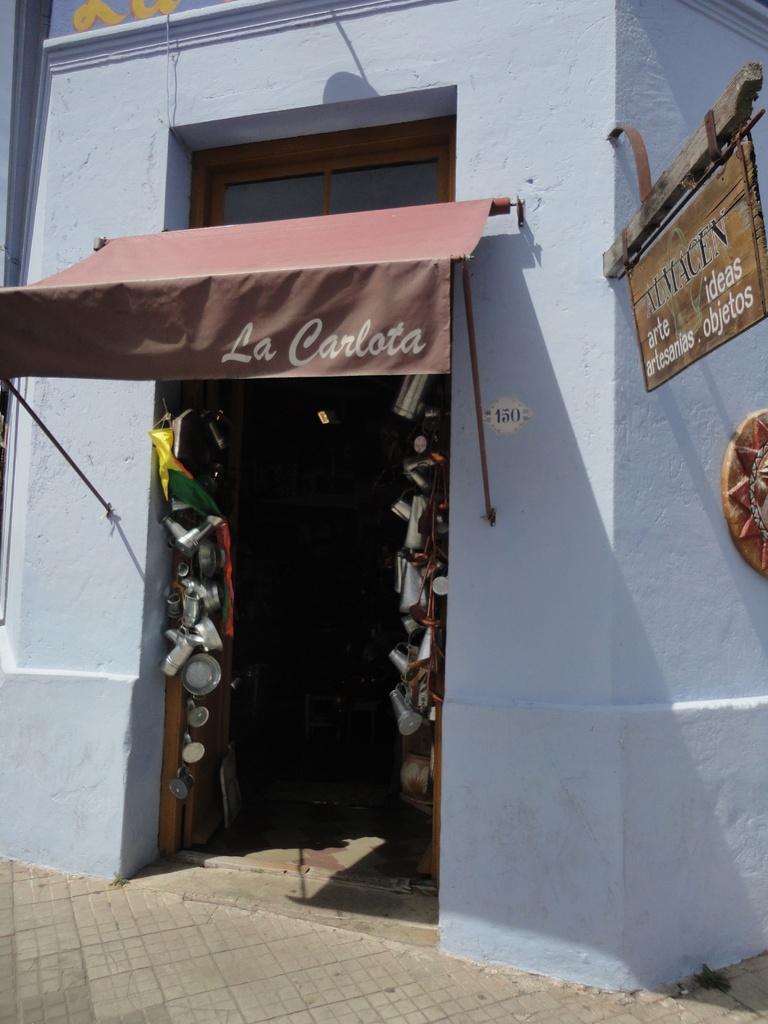How would you summarize this image in a sentence or two? In the center of the image there is a door. There is a sign board. There is a wall. In the bottom of the image there is a road. 